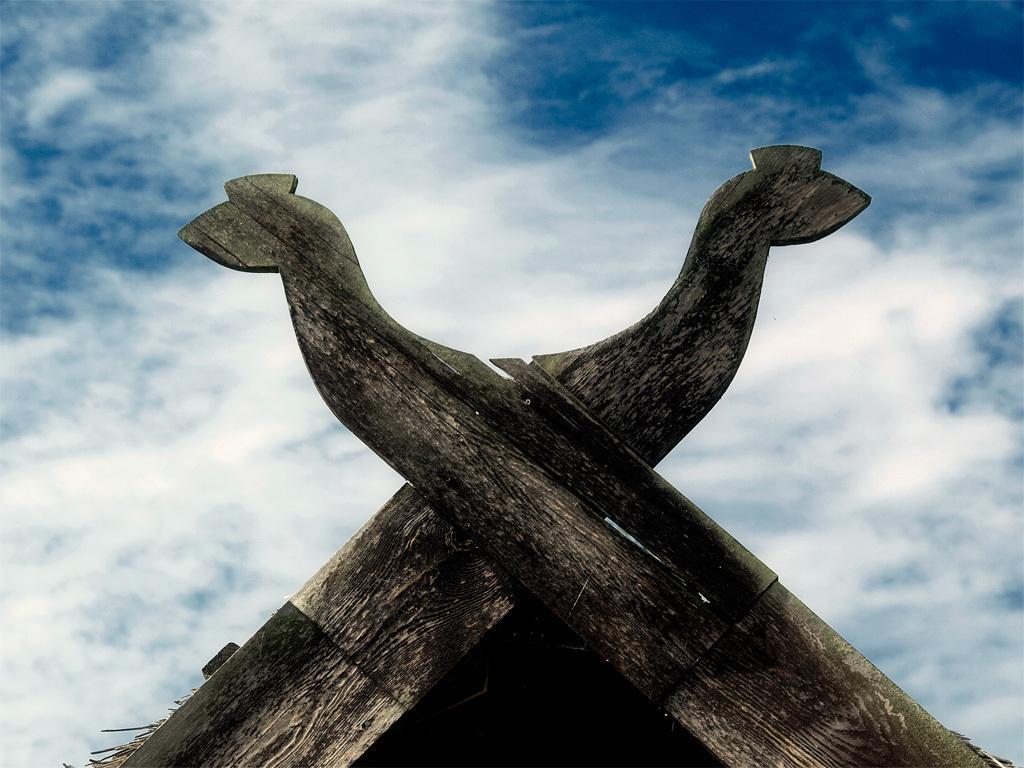Could you give a brief overview of what you see in this image? In this image two wooden planks are carved in the shape of an animal. Background there is sky with clouds. 